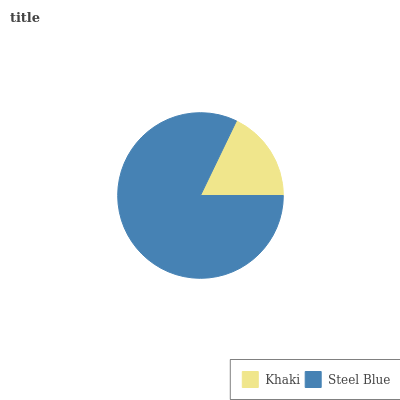Is Khaki the minimum?
Answer yes or no. Yes. Is Steel Blue the maximum?
Answer yes or no. Yes. Is Steel Blue the minimum?
Answer yes or no. No. Is Steel Blue greater than Khaki?
Answer yes or no. Yes. Is Khaki less than Steel Blue?
Answer yes or no. Yes. Is Khaki greater than Steel Blue?
Answer yes or no. No. Is Steel Blue less than Khaki?
Answer yes or no. No. Is Steel Blue the high median?
Answer yes or no. Yes. Is Khaki the low median?
Answer yes or no. Yes. Is Khaki the high median?
Answer yes or no. No. Is Steel Blue the low median?
Answer yes or no. No. 